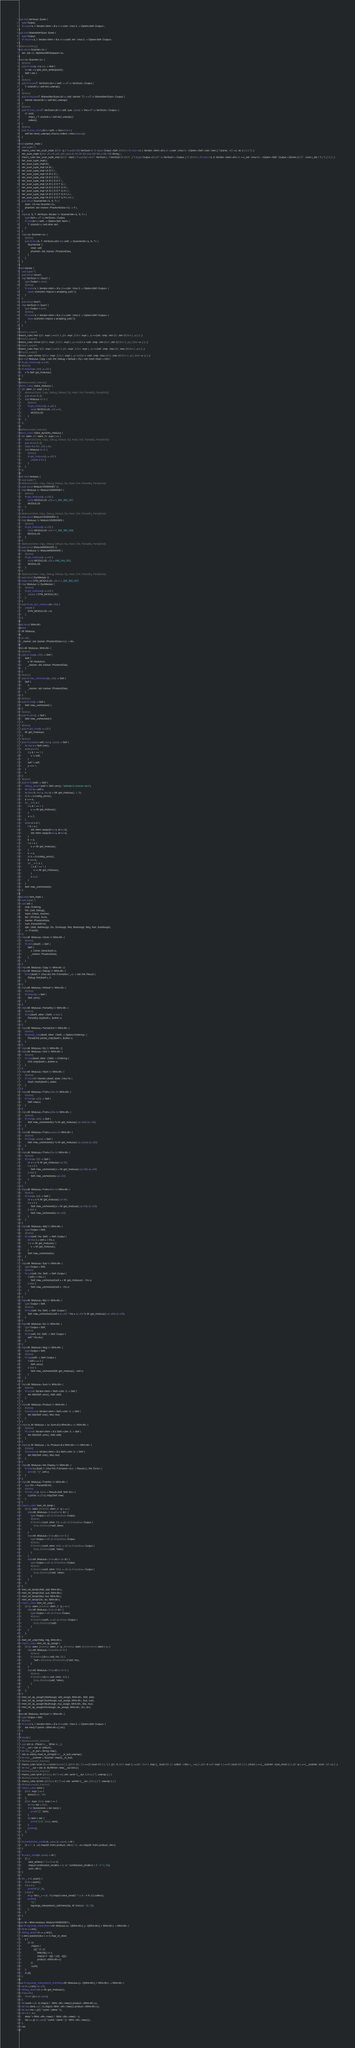Convert code to text. <code><loc_0><loc_0><loc_500><loc_500><_Rust_>pub trait IterScan: Sized {
    type Output;
    fn scan<'a, I: Iterator<Item = &'a str>>(iter: &mut I) -> Option<Self::Output>;
}
pub trait MarkedIterScan: Sized {
    type Output;
    fn mscan<'a, I: Iterator<Item = &'a str>>(self, iter: &mut I) -> Option<Self::Output>;
}
#[derive(Debug)]
pub struct Scanner<'a> {
    iter: std::str::SplitAsciiWhitespace<'a>,
}
impl<'a> Scanner<'a> {
    #[inline]
    pub fn new(s: &'a str) -> Self {
        let iter = s.split_ascii_whitespace();
        Self { iter }
    }
    #[inline]
    pub fn scan<T: IterScan>(&mut self) -> <T as IterScan>::Output {
        T::scan(&mut self.iter).unwrap()
    }
    #[inline]
    pub fn mscan<T: MarkedIterScan>(&mut self, marker: T) -> <T as MarkedIterScan>::Output {
        marker.mscan(&mut self.iter).unwrap()
    }
    #[inline]
    pub fn scan_vec<T: IterScan>(&mut self, size: usize) -> Vec<<T as IterScan>::Output> {
        (0..size)
            .map(|_| T::scan(&mut self.iter).unwrap())
            .collect()
    }
    #[inline]
    pub fn scan_chars(&mut self) -> Vec<char> {
        self.iter.next().unwrap().chars().collect::<Vec<char>>()
    }
}
mod scanner_impls {
    use super::*;
    macro_rules !iter_scan_impls {($($t :ty ) *) =>{$(impl IterScan for $t {type Output =Self ;#[inline ] fn scan <'a ,I :Iterator <Item =&'a str >>(iter :&mut I ) ->Option <Self >{iter .next () ?.parse ::<$t >() .ok () } } ) *} ;}
    iter_scan_impls !(char u8 u16 u32 u64 usize i8 i16 i32 i64 isize f32 f64 u128 i128 String ) ;
    macro_rules !iter_scan_tuple_impl {($($T :ident ) *) =>{impl <$($T :IterScan ) ,*>IterScan for ($($T ,) *) {type Output =($(<$T as IterScan >::Output ,) *) ;#[inline ] fn scan <'a ,It :Iterator <Item =&'a str >>(_iter :&mut It ) ->Option <Self ::Output >{Some (($($T ::scan (_iter ) ?,) *) ) } } } ;}
    iter_scan_tuple_impl!();
    iter_scan_tuple_impl!(A);
    iter_scan_tuple_impl !(A B ) ;
    iter_scan_tuple_impl !(A B C ) ;
    iter_scan_tuple_impl !(A B C D ) ;
    iter_scan_tuple_impl !(A B C D E ) ;
    iter_scan_tuple_impl !(A B C D E F ) ;
    iter_scan_tuple_impl !(A B C D E F G ) ;
    iter_scan_tuple_impl !(A B C D E F G H ) ;
    iter_scan_tuple_impl !(A B C D E F G H I ) ;
    iter_scan_tuple_impl !(A B C D E F G H I J ) ;
    iter_scan_tuple_impl !(A B C D E F G H I J K ) ;
    pub struct ScannerIter<'a, 'b, T> {
        inner: &'b mut Scanner<'a>,
        phantom: std::marker::PhantomData<fn() -> T>,
    }
    impl<'a, 'b, T: IterScan> Iterator for ScannerIter<'a, 'b, T> {
        type Item = <T as IterScan>::Output;
        fn next(&mut self) -> Option<Self::Item> {
            T::scan(&mut self.inner.iter)
        }
    }
    impl<'a> Scanner<'a> {
        #[inline]
        pub fn iter<'b, T: IterScan>(&'b mut self) -> ScannerIter<'a, 'b, T> {
            ScannerIter {
                inner: self,
                phantom: std::marker::PhantomData,
            }
        }
    }
}
mod marker {
    use super::*;
    pub struct Usize1;
    impl IterScan for Usize1 {
        type Output = usize;
        #[inline]
        fn scan<'a, I: Iterator<Item = &'a str>>(iter: &mut I) -> Option<Self::Output> {
            usize::scan(iter).map(|x| x.wrapping_sub(1))
        }
    }
    pub struct Isize1;
    impl IterScan for Isize1 {
        type Output = isize;
        #[inline]
        fn scan<'a, I: Iterator<Item = &'a str>>(iter: &mut I) -> Option<Self::Output> {
            isize::scan(iter).map(|x| x.wrapping_sub(1))
        }
    }
}
#[macro_export]
macro_rules !min {($e :expr ) =>{$e } ;($e :expr ,$($es :expr ) ,+) =>{std ::cmp ::min ($e ,min !($($es ) ,+) ) } ;}
#[macro_export]
macro_rules !chmin {($dst :expr ,$($src :expr ) ,+) =>{{let x =std ::cmp ::min ($dst ,min !($($src ) ,+) ) ;$dst =x ;} } ;}
#[macro_export]
macro_rules !max {($e :expr ) =>{$e } ;($e :expr ,$($es :expr ) ,+) =>{std ::cmp ::max ($e ,max !($($es ) ,+) ) } ;}
#[macro_export]
macro_rules !chmax {($dst :expr ,$($src :expr ) ,+) =>{{let x =std ::cmp ::max ($dst ,max !($($src ) ,+) ) ;$dst =x ;} } ;}
pub trait Modulus: Copy + std::fmt::Debug + Default + Eq + std::hash::Hash + Ord {
    fn get_modulus() -> u32;
    #[inline]
    fn modulo(x: u32) -> u32 {
        x % Self::get_modulus()
    }
}
#[allow(unused_macros)]
macro_rules! make_modulus {
    ($t :ident ,$e :expr ) => {
        #[derive(Clone, Copy, Debug, Default, Eq, Hash, Ord, PartialEq, PartialOrd)]
        pub struct $t {}
        impl Modulus for $t {
            #[inline]
            fn get_modulus() -> u32 {
                const MODULUS: u32 = $e;
                MODULUS
            }
        }
    };
}
#[allow(unused_macros)]
macro_rules! make_dynamic_modulus {
    ($t :ident ,$m :ident ,$e :expr ) => {
        #[derive(Clone, Copy, Debug, Default, Eq, Hash, Ord, PartialEq, PartialOrd)]
        pub struct $t {}
        static mut $m: u32 = $e;
        impl Modulus for $t {
            #[inline]
            fn get_modulus() -> u32 {
                unsafe { $m }
            }
        }
    };
}
pub mod modulus {
    use super::*;
    #[derive(Clone, Copy, Debug, Default, Eq, Hash, Ord, PartialEq, PartialOrd)]
    pub struct Modulo1000000007 {}
    impl Modulus for Modulo1000000007 {
        #[inline]
        fn get_modulus() -> u32 {
            const MODULUS: u32 = 1_000_000_007;
            MODULUS
        }
    }
    #[derive(Clone, Copy, Debug, Default, Eq, Hash, Ord, PartialEq, PartialOrd)]
    pub struct Modulo1000000009 {}
    impl Modulus for Modulo1000000009 {
        #[inline]
        fn get_modulus() -> u32 {
            const MODULUS: u32 = 1_000_000_009;
            MODULUS
        }
    }
    #[derive(Clone, Copy, Debug, Default, Eq, Hash, Ord, PartialEq, PartialOrd)]
    pub struct Modulo998244353 {}
    impl Modulus for Modulo998244353 {
        #[inline]
        fn get_modulus() -> u32 {
            const MODULUS: u32 = 998_244_353;
            MODULUS
        }
    }
    #[derive(Clone, Copy, Debug, Default, Eq, Hash, Ord, PartialEq, PartialOrd)]
    pub struct DynModulo {}
    static mut DYN_MODULUS: u32 = 1_000_000_007;
    impl Modulus for DynModulo {
        #[inline]
        fn get_modulus() -> u32 {
            unsafe { DYN_MODULUS }
        }
    }
    pub fn set_dyn_modulus(m: u32) {
        unsafe {
            DYN_MODULUS = m;
        }
    }
}
pub struct MInt<M>
where
    M: Modulus,
{
    x: u32,
    _marker: std::marker::PhantomData<fn() -> M>,
}
impl<M: Modulus> MInt<M> {
    #[inline]
    pub fn new(x: u32) -> Self {
        Self {
            x: M::modulo(x),
            _marker: std::marker::PhantomData,
        }
    }
    #[inline]
    pub fn new_unchecked(x: u32) -> Self {
        Self {
            x,
            _marker: std::marker::PhantomData,
        }
    }
    #[inline]
    pub fn one() -> Self {
        Self::new_unchecked(1)
    }
    #[inline]
    pub fn zero() -> Self {
        Self::new_unchecked(0)
    }
    #[inline]
    pub fn get_mod() -> u32 {
        M::get_modulus()
    }
    #[inline]
    pub fn pow(mut self, mut y: usize) -> Self {
        let mut x = Self::one();
        while y > 0 {
            if y & 1 == 1 {
                x *= self;
            }
            self *= self;
            y >>= 1;
        }
        x
    }
    #[inline]
    pub fn inv(self) -> Self {
        debug_assert!(self != Self::zero(), "attempt to inverse zero");
        let mut a = self.x;
        let (mut b, mut u, mut s) = (M::get_modulus(), 1, 0);
        let k = a.trailing_zeros();
        a >>= k;
        for _ in 0..k {
            if u & 1 == 1 {
                u += M::get_modulus();
            }
            u /= 2;
        }
        while a != b {
            if b < a {
                std::mem::swap(&mut a, &mut b);
                std::mem::swap(&mut u, &mut s);
            }
            b -= a;
            if s < u {
                s += M::get_modulus();
            }
            s -= u;
            let k = b.trailing_zeros();
            b >>= k;
            for _ in 0..k {
                if s & 1 == 1 {
                    s += M::get_modulus();
                }
                s /= 2;
            }
        }
        Self::new_unchecked(s)
    }
}
pub mod mint_impls {
    use super::*;
    use std::{
        cmp::Ordering,
        fmt::{self, Debug},
        hash::{Hash, Hasher},
        iter::{Product, Sum},
        marker::PhantomData,
        num::ParseIntError,
        ops::{Add, AddAssign, Div, DivAssign, Mul, MulAssign, Neg, Sub, SubAssign},
        str::FromStr,
    };
    impl<M: Modulus> Clone for MInt<M> {
        #[inline]
        fn clone(&self) -> Self {
            Self {
                x: Clone::clone(&self.x),
                _marker: PhantomData,
            }
        }
    }
    impl<M: Modulus> Copy for MInt<M> {}
    impl<M: Modulus> Debug for MInt<M> {
        fn fmt(&self, f: &mut std::fmt::Formatter<'_>) -> std::fmt::Result {
            Debug::fmt(&self.x, f)
        }
    }
    impl<M: Modulus> Default for MInt<M> {
        #[inline]
        fn default() -> Self {
            Self::zero()
        }
    }
    impl<M: Modulus> PartialEq for MInt<M> {
        #[inline]
        fn eq(&self, other: &Self) -> bool {
            PartialEq::eq(&self.x, &other.x)
        }
    }
    impl<M: Modulus> PartialOrd for MInt<M> {
        #[inline]
        fn partial_cmp(&self, other: &Self) -> Option<Ordering> {
            PartialOrd::partial_cmp(&self.x, &other.x)
        }
    }
    impl<M: Modulus> Eq for MInt<M> {}
    impl<M: Modulus> Ord for MInt<M> {
        #[inline]
        fn cmp(&self, other: &Self) -> Ordering {
            Ord::cmp(&self.x, &other.x)
        }
    }
    impl<M: Modulus> Hash for MInt<M> {
        #[inline]
        fn hash<H: Hasher>(&self, state: &mut H) {
            Hash::hash(&self.x, state)
        }
    }
    impl<M: Modulus> From<u32> for MInt<M> {
        #[inline]
        fn from(x: u32) -> Self {
            Self::new(x)
        }
    }
    impl<M: Modulus> From<u64> for MInt<M> {
        #[inline]
        fn from(x: u64) -> Self {
            Self::new_unchecked((x % M::get_modulus() as u64) as u32)
        }
    }
    impl<M: Modulus> From<usize> for MInt<M> {
        #[inline]
        fn from(x: usize) -> Self {
            Self::new_unchecked((x % M::get_modulus() as usize) as u32)
        }
    }
    impl<M: Modulus> From<i32> for MInt<M> {
        #[inline]
        fn from(x: i32) -> Self {
            let x = x % M::get_modulus() as i32;
            if x < 0 {
                Self::new_unchecked((x + M::get_modulus() as i32) as u32)
            } else {
                Self::new_unchecked(x as u32)
            }
        }
    }
    impl<M: Modulus> From<i64> for MInt<M> {
        #[inline]
        fn from(x: i64) -> Self {
            let x = x % M::get_modulus() as i64;
            if x < 0 {
                Self::new_unchecked((x + M::get_modulus() as i64) as u32)
            } else {
                Self::new_unchecked(x as u32)
            }
        }
    }
    impl<M: Modulus> Add for MInt<M> {
        type Output = Self;
        #[inline]
        fn add(self, rhs: Self) -> Self::Output {
            let mut x = self.x + rhs.x;
            if x >= M::get_modulus() {
                x -= M::get_modulus();
            }
            Self::new_unchecked(x)
        }
    }
    impl<M: Modulus> Sub for MInt<M> {
        type Output = Self;
        #[inline]
        fn sub(self, rhs: Self) -> Self::Output {
            if self.x < rhs.x {
                Self::new_unchecked(self.x + M::get_modulus() - rhs.x)
            } else {
                Self::new_unchecked(self.x - rhs.x)
            }
        }
    }
    impl<M: Modulus> Mul for MInt<M> {
        type Output = Self;
        #[inline]
        fn mul(self, rhs: Self) -> Self::Output {
            Self::new_unchecked((self.x as u64 * rhs.x as u64 % M::get_modulus() as u64) as u32)
        }
    }
    impl<M: Modulus> Div for MInt<M> {
        type Output = Self;
        #[inline]
        fn div(self, rhs: Self) -> Self::Output {
            self * rhs.inv()
        }
    }
    impl<M: Modulus> Neg for MInt<M> {
        type Output = Self;
        #[inline]
        fn neg(self) -> Self::Output {
            if self.x == 0 {
                Self::zero()
            } else {
                Self::new_unchecked(M::get_modulus() - self.x)
            }
        }
    }
    impl<M: Modulus> Sum for MInt<M> {
        #[inline]
        fn sum<I: Iterator<Item = Self>>(iter: I) -> Self {
            iter.fold(Self::zero(), Add::add)
        }
    }
    impl<M: Modulus> Product for MInt<M> {
        #[inline]
        fn product<I: Iterator<Item = Self>>(iter: I) -> Self {
            iter.fold(Self::one(), Mul::mul)
        }
    }
    impl<'a, M: Modulus + 'a> Sum<&'a MInt<M>> for MInt<M> {
        #[inline]
        fn sum<I: Iterator<Item = &'a Self>>(iter: I) -> Self {
            iter.fold(Self::zero(), Add::add)
        }
    }
    impl<'a, M: Modulus + 'a> Product<&'a MInt<M>> for MInt<M> {
        #[inline]
        fn product<I: Iterator<Item = &'a Self>>(iter: I) -> Self {
            iter.fold(Self::one(), Mul::mul)
        }
    }
    impl<M: Modulus> fmt::Display for MInt<M> {
        fn fmt<'a>(&self, f: &mut fmt::Formatter<'a>) -> Result<(), fmt::Error> {
            write!(f, "{}", self.x)
        }
    }
    impl<M: Modulus> FromStr for MInt<M> {
        type Err = ParseIntError;
        #[inline]
        fn from_str(s: &str) -> Result<Self, Self::Err> {
            s.parse::<u32>().map(Self::new)
        }
    }
    macro_rules! mint_ref_binop {
        ($imp :ident ,$method :ident ,$t :ty ) => {
            impl<M: Modulus> $imp<$t> for &$t {
                type Output = <$t as $imp<$t>>::Output;
                #[inline]
                fn $method(self, other: $t) -> <$t as $imp<$t>>::Output {
                    $imp::$method(*self, other)
                }
            }
            impl<M: Modulus> $imp<&$t> for $t {
                type Output = <$t as $imp<$t>>::Output;
                #[inline]
                fn $method(self, other: &$t) -> <$t as $imp<$t>>::Output {
                    $imp::$method(self, *other)
                }
            }
            impl<M: Modulus> $imp<&$t> for &$t {
                type Output = <$t as $imp<$t>>::Output;
                #[inline]
                fn $method(self, other: &$t) -> <$t as $imp<$t>>::Output {
                    $imp::$method(*self, *other)
                }
            }
        };
    }
    mint_ref_binop!(Add, add, MInt<M>);
    mint_ref_binop!(Sub, sub, MInt<M>);
    mint_ref_binop!(Mul, mul, MInt<M>);
    mint_ref_binop!(Div, div, MInt<M>);
    macro_rules! mint_ref_unop {
        ($imp :ident ,$method :ident ,$t :ty ) => {
            impl<M: Modulus> $imp for &$t {
                type Output = <$t as $imp>::Output;
                #[inline]
                fn $method(self) -> <$t as $imp>::Output {
                    $imp::$method(*self)
                }
            }
        };
    }
    mint_ref_unop!(Neg, neg, MInt<M>);
    macro_rules! mint_ref_op_assign {
        ($imp :ident ,$method :ident ,$t :ty ,$fromimp :ident ,$frommethod :ident ) => {
            impl<M: Modulus> $imp<$t> for $t {
                #[inline]
                fn $method(&mut self, rhs: $t) {
                    *self = $fromimp::$frommethod(*self, rhs);
                }
            }
            impl<M: Modulus> $imp<&$t> for $t {
                #[inline]
                fn $method(&mut self, other: &$t) {
                    $imp::$method(self, *other);
                }
            }
        };
    }
    mint_ref_op_assign!(AddAssign, add_assign, MInt<M>, Add, add);
    mint_ref_op_assign!(SubAssign, sub_assign, MInt<M>, Sub, sub);
    mint_ref_op_assign!(MulAssign, mul_assign, MInt<M>, Mul, mul);
    mint_ref_op_assign!(DivAssign, div_assign, MInt<M>, Div, div);
}
impl<M: Modulus> IterScan for MInt<M> {
    type Output = Self;
    #[inline]
    fn scan<'a, I: Iterator<Item = &'a str>>(iter: &mut I) -> Option<Self::Output> {
        iter.next()?.parse::<MInt<M>>().ok()
    }
}
fn main() {
    #[allow(unused_imports)]
    use std::io::{Read as _, Write as _};
    let __out = std::io::stdout();
    let mut __in_buf = String::new();
    std::io::stdin().read_to_string(&mut __in_buf).unwrap();
    let mut __scanner = Scanner::new(&__in_buf);
    #[allow(unused_macros)]
    macro_rules !scan {() =>{scan !(usize ) } ;(($($t :tt ) ,*) ) =>{($(scan !($t ) ) ,*) } ;([$t :tt ;$len :expr ] ) =>{(0 ..$len ) .map (|_ |scan !($t ) ) .collect ::<Vec <_ >>() } ;({$t :tt =>$f :expr } ) =>{$f (scan !($t ) ) } ;(chars ) =>{__scanner .scan_chars () } ;($t :ty ) =>{__scanner .scan ::<$t >() } ;}
    let mut __out = std::io::BufWriter::new(__out.lock());
    #[allow(unused_macros)]
    macro_rules !print {($($arg :tt ) *) =>(::std ::write !(__out ,$($arg ) *) .unwrap () ) }
    #[allow(unused_macros)]
    macro_rules !println {($($arg :tt ) *) =>(::std ::writeln !(__out ,$($arg ) *) .unwrap () ) }
    #[allow(unused_macros)]
    macro_rules! echo {
        ($iter :expr ) => {
            echo!($iter, "\n")
        };
        ($iter :expr ,$sep :expr ) => {
            let mut iter = $iter;
            if let Some(item) = iter.next() {
                print!("{}", item);
            }
            for item in iter {
                print!("{}{}", $sep, item);
            }
            println!();
        };
    }

    fn combination_smallk(n: usize, k: usize) -> M {
        (n + 1 - k..=n).map(M::from).product::<M>() / (1..=k).map(M::from).product::<M>()
    }

    fn solve_small(n: usize) -> M {
        (0..)
            .take_while(|i| i * 2 + 5 <= n)
            .map(|i| combination_smallk(i + 4, 4) * combination_smallk(n + 5 - 2 * i, 10))
            .sum::<M>()
    }

    for _ in 0..scan!() {
        let n = scan!();
        if n < 5 {
            println!("{}", 0);
        } else {
            let y: Vec<_> = (0..16).map(|i| solve_small(2 * i + 6 - n % 2)).collect();
            println!(
                "{}",
                lagrange_interpolation_arithmetic(&y, M::from((n - 5) / 2))
            );
        }
    }
}
type M = MInt<modulus::Modulo1000000007>;
pub fn lagrange_interpolation<M: Modulus>(x: &[MInt<M>], y: &[MInt<M>], t: MInt<M>) -> MInt<M> {
    let n = x.len();
    debug_assert!(n == y.len());
    x.iter().position(|&x| x == t).map_or_else(
        || {
            (0..n)
                .map(|i| {
                    y[i] * (0..n)
                        .filter(|&j| j != i)
                        .map(|j| (t - x[j]) / (x[i] - x[j]))
                        .product::<MInt<M>>()
                })
                .sum()
        },
        |i| y[i],
    )
}
pub fn lagrange_interpolation_arithmetic<M: Modulus>(y: &[MInt<M>], t: MInt<M>) -> MInt<M> {
    let n = y.len() as u32;
    debug_assert!(n <= M::get_modulus());
    if t.x < n {
        return y[t.x as usize];
    }
    let nume = (0..n).map(|i| t - MInt::<M>::new(i)).product::<MInt<M>>();
    let mut deno = (1..n).map(|i| -MInt::<M>::new(i)).product::<MInt<M>>();
    let mut res = y[0] * nume / (deno * t);
    for i in 1..n {
        deno *= MInt::<M>::new(i) / -MInt::<M>::new(n - i);
        res += y[i as usize] * nume / (deno * (t - MInt::<M>::new(i)));
    }
    res
}</code> 